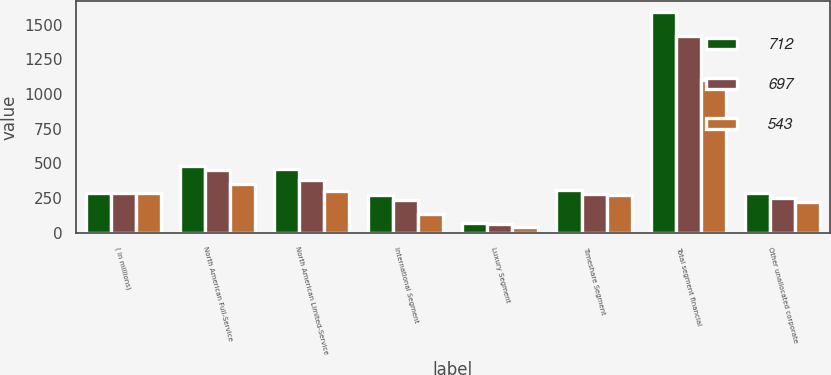Convert chart to OTSL. <chart><loc_0><loc_0><loc_500><loc_500><stacked_bar_chart><ecel><fcel>( in millions)<fcel>North American Full-Service<fcel>North American Limited-Service<fcel>International Segment<fcel>Luxury Segment<fcel>Timeshare Segment<fcel>Total segment financial<fcel>Other unallocated corporate<nl><fcel>712<fcel>287<fcel>478<fcel>461<fcel>271<fcel>72<fcel>306<fcel>1588<fcel>287<nl><fcel>697<fcel>287<fcel>455<fcel>380<fcel>237<fcel>63<fcel>280<fcel>1415<fcel>251<nl><fcel>543<fcel>287<fcel>349<fcel>303<fcel>133<fcel>45<fcel>271<fcel>1101<fcel>219<nl></chart> 